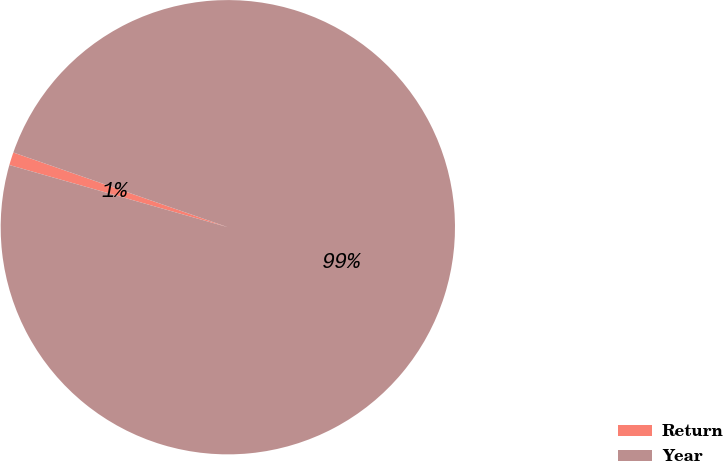Convert chart. <chart><loc_0><loc_0><loc_500><loc_500><pie_chart><fcel>Return<fcel>Year<nl><fcel>0.92%<fcel>99.08%<nl></chart> 